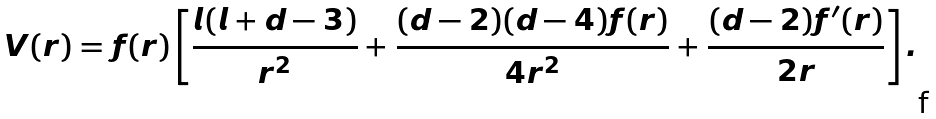<formula> <loc_0><loc_0><loc_500><loc_500>V ( r ) = f ( r ) \left [ \frac { l ( l + d - 3 ) } { r ^ { 2 } } + \frac { ( d - 2 ) ( d - 4 ) f ( r ) } { 4 r ^ { 2 } } + \frac { ( d - 2 ) f ^ { \prime } ( r ) } { 2 r } \right ] .</formula> 